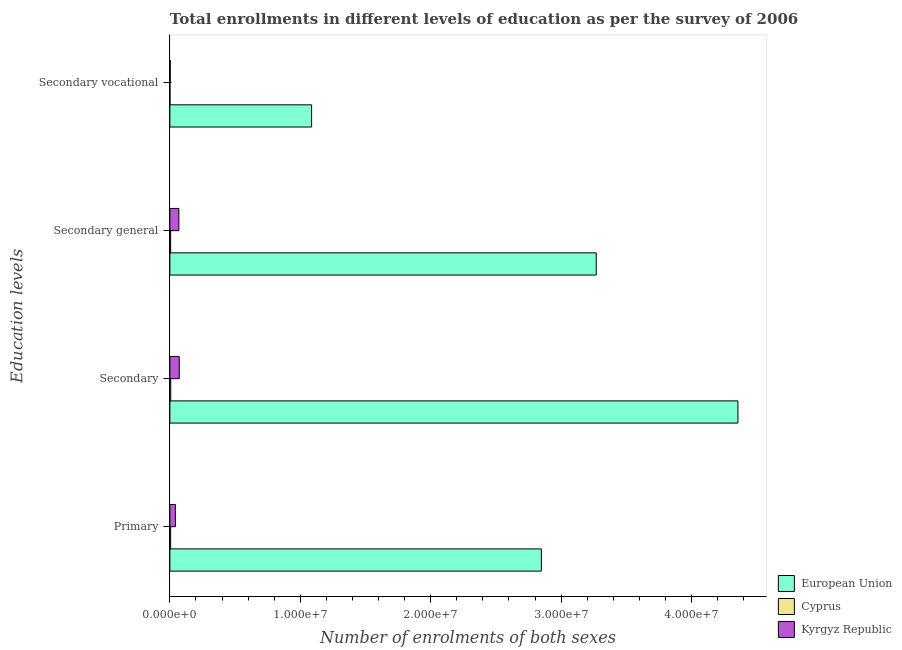How many different coloured bars are there?
Ensure brevity in your answer.  3. How many groups of bars are there?
Ensure brevity in your answer.  4. Are the number of bars on each tick of the Y-axis equal?
Offer a terse response. Yes. How many bars are there on the 3rd tick from the top?
Provide a succinct answer. 3. What is the label of the 3rd group of bars from the top?
Ensure brevity in your answer.  Secondary. What is the number of enrolments in primary education in Kyrgyz Republic?
Give a very brief answer. 4.24e+05. Across all countries, what is the maximum number of enrolments in secondary vocational education?
Ensure brevity in your answer.  1.09e+07. Across all countries, what is the minimum number of enrolments in secondary vocational education?
Give a very brief answer. 4304. In which country was the number of enrolments in secondary general education maximum?
Your response must be concise. European Union. In which country was the number of enrolments in secondary education minimum?
Offer a terse response. Cyprus. What is the total number of enrolments in primary education in the graph?
Ensure brevity in your answer.  2.90e+07. What is the difference between the number of enrolments in primary education in European Union and that in Cyprus?
Give a very brief answer. 2.84e+07. What is the difference between the number of enrolments in secondary vocational education in Kyrgyz Republic and the number of enrolments in primary education in Cyprus?
Ensure brevity in your answer.  -3.11e+04. What is the average number of enrolments in primary education per country?
Keep it short and to the point. 9.66e+06. What is the difference between the number of enrolments in primary education and number of enrolments in secondary general education in Cyprus?
Your response must be concise. -700. What is the ratio of the number of enrolments in primary education in Cyprus to that in European Union?
Offer a terse response. 0. Is the difference between the number of enrolments in secondary vocational education in European Union and Kyrgyz Republic greater than the difference between the number of enrolments in primary education in European Union and Kyrgyz Republic?
Give a very brief answer. No. What is the difference between the highest and the second highest number of enrolments in primary education?
Keep it short and to the point. 2.81e+07. What is the difference between the highest and the lowest number of enrolments in secondary education?
Your answer should be compact. 4.35e+07. What does the 2nd bar from the top in Primary represents?
Provide a short and direct response. Cyprus. What does the 2nd bar from the bottom in Secondary general represents?
Your answer should be very brief. Cyprus. Is it the case that in every country, the sum of the number of enrolments in primary education and number of enrolments in secondary education is greater than the number of enrolments in secondary general education?
Provide a short and direct response. Yes. How many countries are there in the graph?
Provide a succinct answer. 3. Are the values on the major ticks of X-axis written in scientific E-notation?
Your answer should be compact. Yes. Does the graph contain any zero values?
Your answer should be compact. No. Does the graph contain grids?
Provide a succinct answer. No. How many legend labels are there?
Your response must be concise. 3. What is the title of the graph?
Your answer should be very brief. Total enrollments in different levels of education as per the survey of 2006. Does "Colombia" appear as one of the legend labels in the graph?
Your answer should be very brief. No. What is the label or title of the X-axis?
Your response must be concise. Number of enrolments of both sexes. What is the label or title of the Y-axis?
Your response must be concise. Education levels. What is the Number of enrolments of both sexes in European Union in Primary?
Offer a terse response. 2.85e+07. What is the Number of enrolments of both sexes of Cyprus in Primary?
Your answer should be compact. 5.97e+04. What is the Number of enrolments of both sexes of Kyrgyz Republic in Primary?
Your answer should be compact. 4.24e+05. What is the Number of enrolments of both sexes of European Union in Secondary?
Offer a very short reply. 4.36e+07. What is the Number of enrolments of both sexes of Cyprus in Secondary?
Offer a terse response. 6.47e+04. What is the Number of enrolments of both sexes in Kyrgyz Republic in Secondary?
Provide a short and direct response. 7.19e+05. What is the Number of enrolments of both sexes of European Union in Secondary general?
Provide a succinct answer. 3.27e+07. What is the Number of enrolments of both sexes in Cyprus in Secondary general?
Offer a terse response. 6.04e+04. What is the Number of enrolments of both sexes in Kyrgyz Republic in Secondary general?
Ensure brevity in your answer.  6.90e+05. What is the Number of enrolments of both sexes of European Union in Secondary vocational?
Provide a short and direct response. 1.09e+07. What is the Number of enrolments of both sexes of Cyprus in Secondary vocational?
Keep it short and to the point. 4304. What is the Number of enrolments of both sexes of Kyrgyz Republic in Secondary vocational?
Provide a short and direct response. 2.86e+04. Across all Education levels, what is the maximum Number of enrolments of both sexes in European Union?
Your response must be concise. 4.36e+07. Across all Education levels, what is the maximum Number of enrolments of both sexes in Cyprus?
Make the answer very short. 6.47e+04. Across all Education levels, what is the maximum Number of enrolments of both sexes in Kyrgyz Republic?
Your response must be concise. 7.19e+05. Across all Education levels, what is the minimum Number of enrolments of both sexes of European Union?
Your answer should be compact. 1.09e+07. Across all Education levels, what is the minimum Number of enrolments of both sexes of Cyprus?
Give a very brief answer. 4304. Across all Education levels, what is the minimum Number of enrolments of both sexes in Kyrgyz Republic?
Your response must be concise. 2.86e+04. What is the total Number of enrolments of both sexes in European Union in the graph?
Provide a succinct answer. 1.16e+08. What is the total Number of enrolments of both sexes in Cyprus in the graph?
Offer a very short reply. 1.89e+05. What is the total Number of enrolments of both sexes of Kyrgyz Republic in the graph?
Give a very brief answer. 1.86e+06. What is the difference between the Number of enrolments of both sexes of European Union in Primary and that in Secondary?
Provide a succinct answer. -1.51e+07. What is the difference between the Number of enrolments of both sexes of Cyprus in Primary and that in Secondary?
Ensure brevity in your answer.  -5004. What is the difference between the Number of enrolments of both sexes of Kyrgyz Republic in Primary and that in Secondary?
Provide a succinct answer. -2.95e+05. What is the difference between the Number of enrolments of both sexes of European Union in Primary and that in Secondary general?
Your answer should be very brief. -4.21e+06. What is the difference between the Number of enrolments of both sexes of Cyprus in Primary and that in Secondary general?
Ensure brevity in your answer.  -700. What is the difference between the Number of enrolments of both sexes in Kyrgyz Republic in Primary and that in Secondary general?
Provide a short and direct response. -2.66e+05. What is the difference between the Number of enrolments of both sexes of European Union in Primary and that in Secondary vocational?
Offer a terse response. 1.76e+07. What is the difference between the Number of enrolments of both sexes in Cyprus in Primary and that in Secondary vocational?
Offer a very short reply. 5.54e+04. What is the difference between the Number of enrolments of both sexes of Kyrgyz Republic in Primary and that in Secondary vocational?
Provide a succinct answer. 3.95e+05. What is the difference between the Number of enrolments of both sexes of European Union in Secondary and that in Secondary general?
Provide a succinct answer. 1.09e+07. What is the difference between the Number of enrolments of both sexes of Cyprus in Secondary and that in Secondary general?
Your response must be concise. 4304. What is the difference between the Number of enrolments of both sexes of Kyrgyz Republic in Secondary and that in Secondary general?
Your answer should be very brief. 2.86e+04. What is the difference between the Number of enrolments of both sexes of European Union in Secondary and that in Secondary vocational?
Your answer should be very brief. 3.27e+07. What is the difference between the Number of enrolments of both sexes in Cyprus in Secondary and that in Secondary vocational?
Offer a very short reply. 6.04e+04. What is the difference between the Number of enrolments of both sexes of Kyrgyz Republic in Secondary and that in Secondary vocational?
Provide a succinct answer. 6.90e+05. What is the difference between the Number of enrolments of both sexes in European Union in Secondary general and that in Secondary vocational?
Give a very brief answer. 2.18e+07. What is the difference between the Number of enrolments of both sexes in Cyprus in Secondary general and that in Secondary vocational?
Give a very brief answer. 5.61e+04. What is the difference between the Number of enrolments of both sexes in Kyrgyz Republic in Secondary general and that in Secondary vocational?
Make the answer very short. 6.61e+05. What is the difference between the Number of enrolments of both sexes in European Union in Primary and the Number of enrolments of both sexes in Cyprus in Secondary?
Ensure brevity in your answer.  2.84e+07. What is the difference between the Number of enrolments of both sexes of European Union in Primary and the Number of enrolments of both sexes of Kyrgyz Republic in Secondary?
Offer a very short reply. 2.78e+07. What is the difference between the Number of enrolments of both sexes in Cyprus in Primary and the Number of enrolments of both sexes in Kyrgyz Republic in Secondary?
Your response must be concise. -6.59e+05. What is the difference between the Number of enrolments of both sexes of European Union in Primary and the Number of enrolments of both sexes of Cyprus in Secondary general?
Ensure brevity in your answer.  2.84e+07. What is the difference between the Number of enrolments of both sexes of European Union in Primary and the Number of enrolments of both sexes of Kyrgyz Republic in Secondary general?
Make the answer very short. 2.78e+07. What is the difference between the Number of enrolments of both sexes of Cyprus in Primary and the Number of enrolments of both sexes of Kyrgyz Republic in Secondary general?
Offer a terse response. -6.30e+05. What is the difference between the Number of enrolments of both sexes in European Union in Primary and the Number of enrolments of both sexes in Cyprus in Secondary vocational?
Provide a succinct answer. 2.85e+07. What is the difference between the Number of enrolments of both sexes of European Union in Primary and the Number of enrolments of both sexes of Kyrgyz Republic in Secondary vocational?
Your answer should be compact. 2.85e+07. What is the difference between the Number of enrolments of both sexes in Cyprus in Primary and the Number of enrolments of both sexes in Kyrgyz Republic in Secondary vocational?
Give a very brief answer. 3.11e+04. What is the difference between the Number of enrolments of both sexes in European Union in Secondary and the Number of enrolments of both sexes in Cyprus in Secondary general?
Offer a very short reply. 4.35e+07. What is the difference between the Number of enrolments of both sexes in European Union in Secondary and the Number of enrolments of both sexes in Kyrgyz Republic in Secondary general?
Give a very brief answer. 4.29e+07. What is the difference between the Number of enrolments of both sexes of Cyprus in Secondary and the Number of enrolments of both sexes of Kyrgyz Republic in Secondary general?
Offer a very short reply. -6.25e+05. What is the difference between the Number of enrolments of both sexes of European Union in Secondary and the Number of enrolments of both sexes of Cyprus in Secondary vocational?
Your answer should be compact. 4.36e+07. What is the difference between the Number of enrolments of both sexes of European Union in Secondary and the Number of enrolments of both sexes of Kyrgyz Republic in Secondary vocational?
Offer a terse response. 4.35e+07. What is the difference between the Number of enrolments of both sexes in Cyprus in Secondary and the Number of enrolments of both sexes in Kyrgyz Republic in Secondary vocational?
Make the answer very short. 3.61e+04. What is the difference between the Number of enrolments of both sexes of European Union in Secondary general and the Number of enrolments of both sexes of Cyprus in Secondary vocational?
Your answer should be very brief. 3.27e+07. What is the difference between the Number of enrolments of both sexes in European Union in Secondary general and the Number of enrolments of both sexes in Kyrgyz Republic in Secondary vocational?
Make the answer very short. 3.27e+07. What is the difference between the Number of enrolments of both sexes in Cyprus in Secondary general and the Number of enrolments of both sexes in Kyrgyz Republic in Secondary vocational?
Offer a very short reply. 3.18e+04. What is the average Number of enrolments of both sexes of European Union per Education levels?
Offer a terse response. 2.89e+07. What is the average Number of enrolments of both sexes in Cyprus per Education levels?
Keep it short and to the point. 4.73e+04. What is the average Number of enrolments of both sexes of Kyrgyz Republic per Education levels?
Keep it short and to the point. 4.65e+05. What is the difference between the Number of enrolments of both sexes of European Union and Number of enrolments of both sexes of Cyprus in Primary?
Keep it short and to the point. 2.84e+07. What is the difference between the Number of enrolments of both sexes of European Union and Number of enrolments of both sexes of Kyrgyz Republic in Primary?
Provide a succinct answer. 2.81e+07. What is the difference between the Number of enrolments of both sexes of Cyprus and Number of enrolments of both sexes of Kyrgyz Republic in Primary?
Offer a very short reply. -3.64e+05. What is the difference between the Number of enrolments of both sexes in European Union and Number of enrolments of both sexes in Cyprus in Secondary?
Your response must be concise. 4.35e+07. What is the difference between the Number of enrolments of both sexes in European Union and Number of enrolments of both sexes in Kyrgyz Republic in Secondary?
Ensure brevity in your answer.  4.28e+07. What is the difference between the Number of enrolments of both sexes in Cyprus and Number of enrolments of both sexes in Kyrgyz Republic in Secondary?
Your response must be concise. -6.54e+05. What is the difference between the Number of enrolments of both sexes in European Union and Number of enrolments of both sexes in Cyprus in Secondary general?
Your response must be concise. 3.26e+07. What is the difference between the Number of enrolments of both sexes of European Union and Number of enrolments of both sexes of Kyrgyz Republic in Secondary general?
Make the answer very short. 3.20e+07. What is the difference between the Number of enrolments of both sexes in Cyprus and Number of enrolments of both sexes in Kyrgyz Republic in Secondary general?
Your answer should be compact. -6.30e+05. What is the difference between the Number of enrolments of both sexes of European Union and Number of enrolments of both sexes of Cyprus in Secondary vocational?
Provide a short and direct response. 1.09e+07. What is the difference between the Number of enrolments of both sexes in European Union and Number of enrolments of both sexes in Kyrgyz Republic in Secondary vocational?
Provide a short and direct response. 1.08e+07. What is the difference between the Number of enrolments of both sexes of Cyprus and Number of enrolments of both sexes of Kyrgyz Republic in Secondary vocational?
Keep it short and to the point. -2.43e+04. What is the ratio of the Number of enrolments of both sexes in European Union in Primary to that in Secondary?
Your response must be concise. 0.65. What is the ratio of the Number of enrolments of both sexes in Cyprus in Primary to that in Secondary?
Offer a terse response. 0.92. What is the ratio of the Number of enrolments of both sexes in Kyrgyz Republic in Primary to that in Secondary?
Give a very brief answer. 0.59. What is the ratio of the Number of enrolments of both sexes in European Union in Primary to that in Secondary general?
Keep it short and to the point. 0.87. What is the ratio of the Number of enrolments of both sexes in Cyprus in Primary to that in Secondary general?
Offer a terse response. 0.99. What is the ratio of the Number of enrolments of both sexes of Kyrgyz Republic in Primary to that in Secondary general?
Offer a very short reply. 0.61. What is the ratio of the Number of enrolments of both sexes of European Union in Primary to that in Secondary vocational?
Your answer should be very brief. 2.62. What is the ratio of the Number of enrolments of both sexes in Cyprus in Primary to that in Secondary vocational?
Your answer should be compact. 13.87. What is the ratio of the Number of enrolments of both sexes in Kyrgyz Republic in Primary to that in Secondary vocational?
Keep it short and to the point. 14.81. What is the ratio of the Number of enrolments of both sexes in European Union in Secondary to that in Secondary general?
Keep it short and to the point. 1.33. What is the ratio of the Number of enrolments of both sexes of Cyprus in Secondary to that in Secondary general?
Provide a short and direct response. 1.07. What is the ratio of the Number of enrolments of both sexes of Kyrgyz Republic in Secondary to that in Secondary general?
Provide a succinct answer. 1.04. What is the ratio of the Number of enrolments of both sexes of European Union in Secondary to that in Secondary vocational?
Ensure brevity in your answer.  4.01. What is the ratio of the Number of enrolments of both sexes of Cyprus in Secondary to that in Secondary vocational?
Provide a short and direct response. 15.04. What is the ratio of the Number of enrolments of both sexes in Kyrgyz Republic in Secondary to that in Secondary vocational?
Ensure brevity in your answer.  25.11. What is the ratio of the Number of enrolments of both sexes of European Union in Secondary general to that in Secondary vocational?
Give a very brief answer. 3.01. What is the ratio of the Number of enrolments of both sexes of Cyprus in Secondary general to that in Secondary vocational?
Keep it short and to the point. 14.04. What is the ratio of the Number of enrolments of both sexes in Kyrgyz Republic in Secondary general to that in Secondary vocational?
Your answer should be very brief. 24.11. What is the difference between the highest and the second highest Number of enrolments of both sexes of European Union?
Give a very brief answer. 1.09e+07. What is the difference between the highest and the second highest Number of enrolments of both sexes in Cyprus?
Make the answer very short. 4304. What is the difference between the highest and the second highest Number of enrolments of both sexes in Kyrgyz Republic?
Your answer should be compact. 2.86e+04. What is the difference between the highest and the lowest Number of enrolments of both sexes in European Union?
Provide a succinct answer. 3.27e+07. What is the difference between the highest and the lowest Number of enrolments of both sexes in Cyprus?
Your answer should be compact. 6.04e+04. What is the difference between the highest and the lowest Number of enrolments of both sexes of Kyrgyz Republic?
Ensure brevity in your answer.  6.90e+05. 